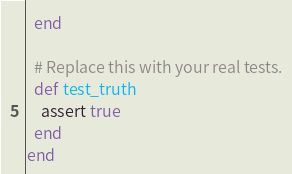<code> <loc_0><loc_0><loc_500><loc_500><_Ruby_>  end

  # Replace this with your real tests.
  def test_truth
    assert true
  end
end
</code> 